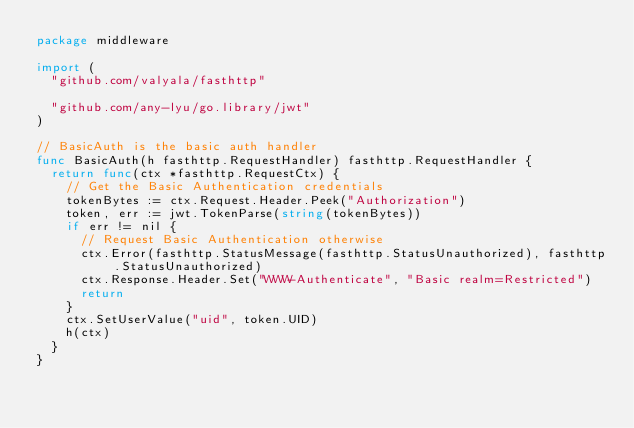<code> <loc_0><loc_0><loc_500><loc_500><_Go_>package middleware

import (
	"github.com/valyala/fasthttp"

	"github.com/any-lyu/go.library/jwt"
)

// BasicAuth is the basic auth handler
func BasicAuth(h fasthttp.RequestHandler) fasthttp.RequestHandler {
	return func(ctx *fasthttp.RequestCtx) {
		// Get the Basic Authentication credentials
		tokenBytes := ctx.Request.Header.Peek("Authorization")
		token, err := jwt.TokenParse(string(tokenBytes))
		if err != nil {
			// Request Basic Authentication otherwise
			ctx.Error(fasthttp.StatusMessage(fasthttp.StatusUnauthorized), fasthttp.StatusUnauthorized)
			ctx.Response.Header.Set("WWW-Authenticate", "Basic realm=Restricted")
			return
		}
		ctx.SetUserValue("uid", token.UID)
		h(ctx)
	}
}
</code> 